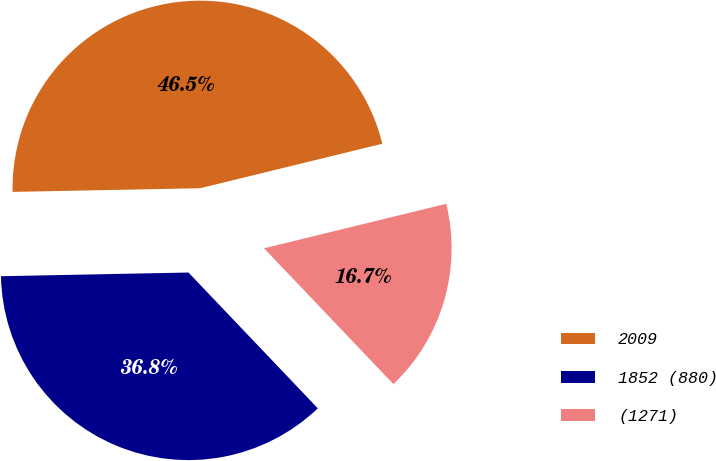Convert chart to OTSL. <chart><loc_0><loc_0><loc_500><loc_500><pie_chart><fcel>2009<fcel>1852 (880)<fcel>(1271)<nl><fcel>46.5%<fcel>36.8%<fcel>16.7%<nl></chart> 